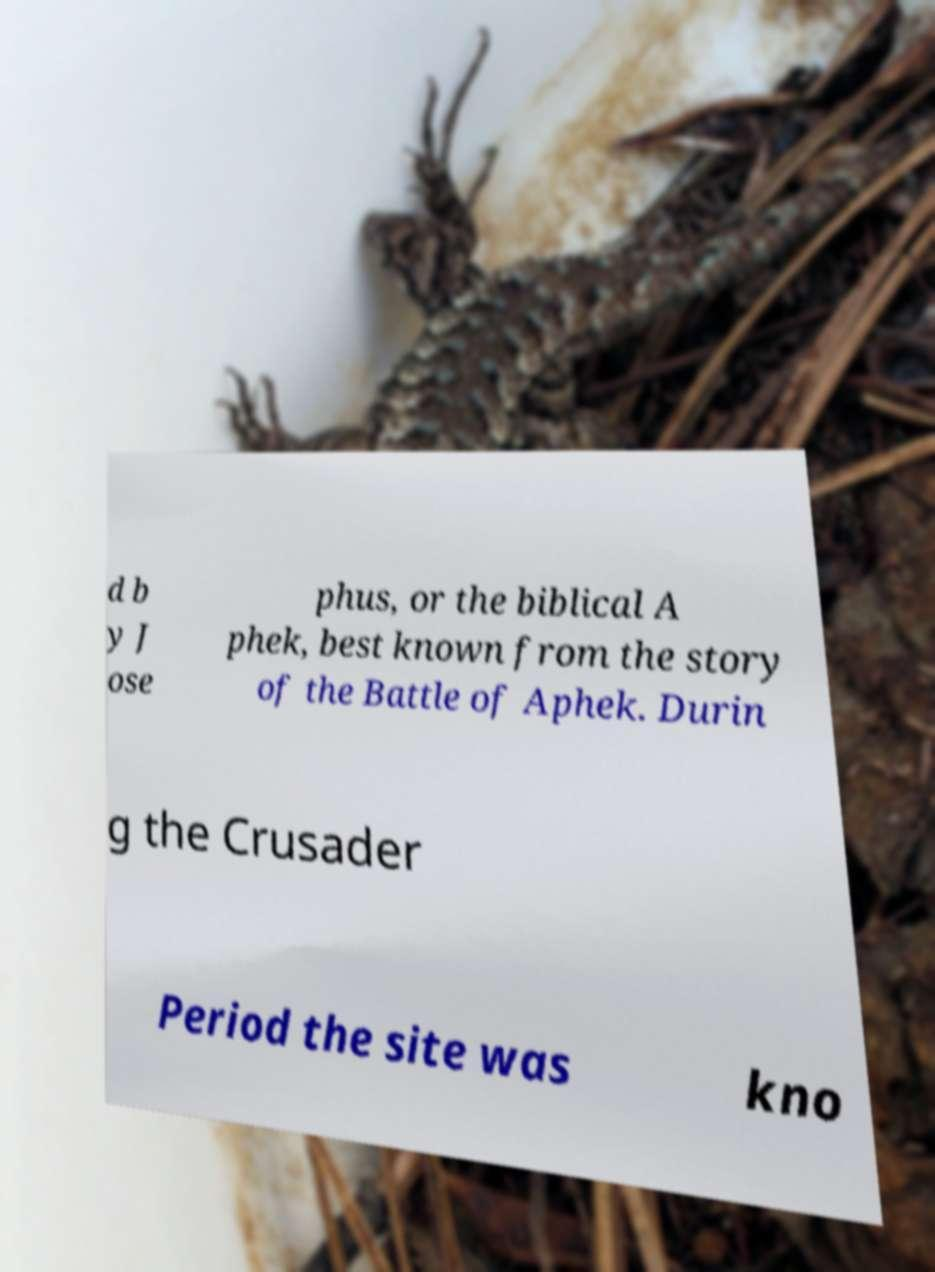For documentation purposes, I need the text within this image transcribed. Could you provide that? d b y J ose phus, or the biblical A phek, best known from the story of the Battle of Aphek. Durin g the Crusader Period the site was kno 